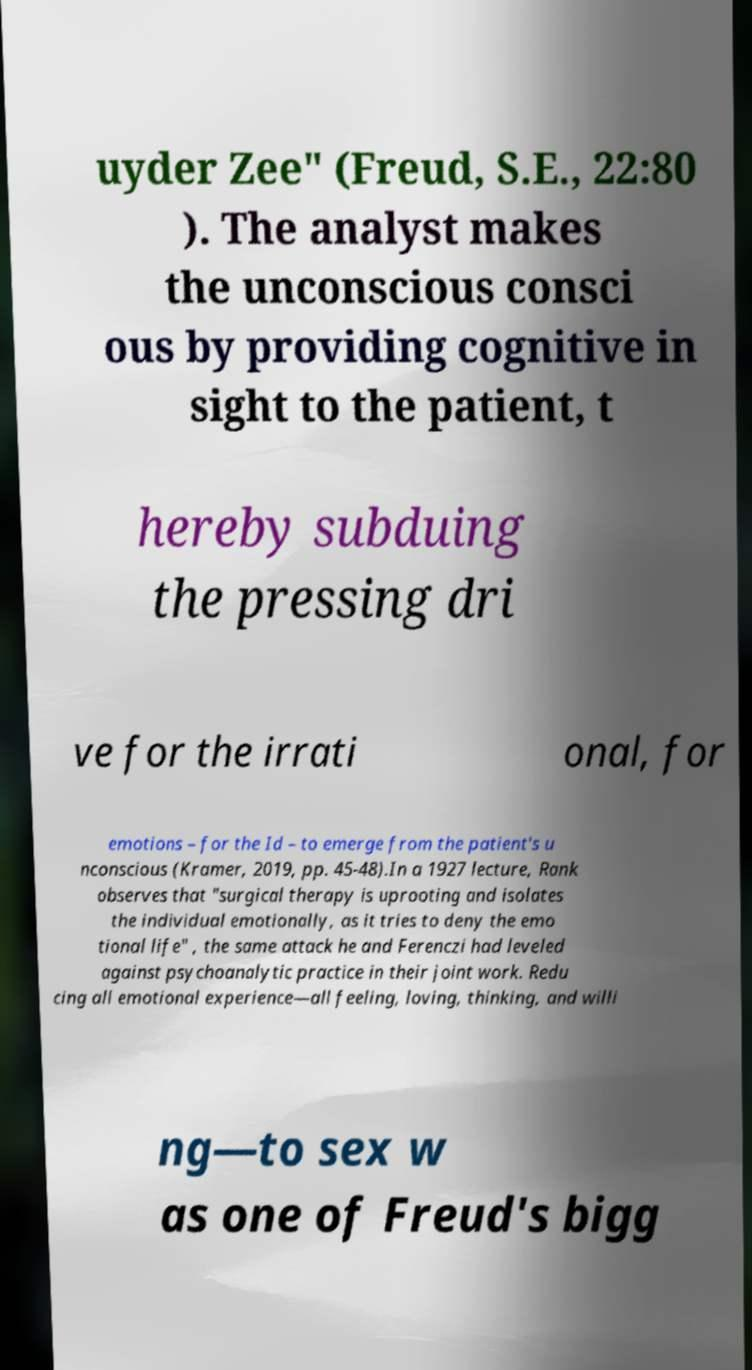I need the written content from this picture converted into text. Can you do that? uyder Zee" (Freud, S.E., 22:80 ). The analyst makes the unconscious consci ous by providing cognitive in sight to the patient, t hereby subduing the pressing dri ve for the irrati onal, for emotions – for the Id – to emerge from the patient's u nconscious (Kramer, 2019, pp. 45-48).In a 1927 lecture, Rank observes that "surgical therapy is uprooting and isolates the individual emotionally, as it tries to deny the emo tional life" , the same attack he and Ferenczi had leveled against psychoanalytic practice in their joint work. Redu cing all emotional experience—all feeling, loving, thinking, and willi ng—to sex w as one of Freud's bigg 